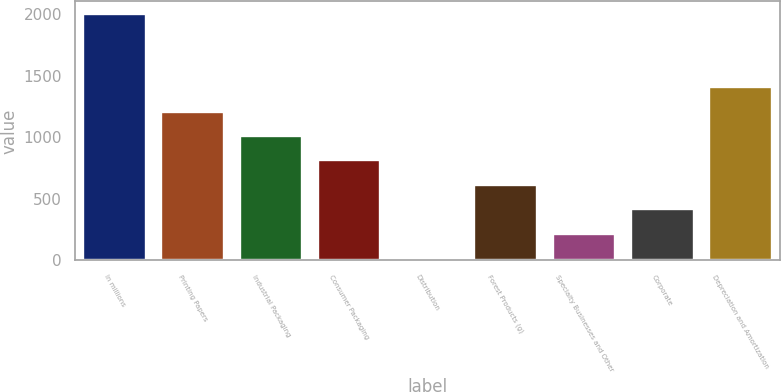Convert chart to OTSL. <chart><loc_0><loc_0><loc_500><loc_500><bar_chart><fcel>In millions<fcel>Printing Papers<fcel>Industrial Packaging<fcel>Consumer Packaging<fcel>Distribution<fcel>Forest Products (g)<fcel>Specialty Businesses and Other<fcel>Corporate<fcel>Depreciation and Amortization<nl><fcel>2004<fcel>1209.2<fcel>1010.5<fcel>811.8<fcel>17<fcel>613.1<fcel>215.7<fcel>414.4<fcel>1407.9<nl></chart> 